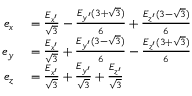<formula> <loc_0><loc_0><loc_500><loc_500>\begin{array} { r l } { e _ { x } } & = \frac { E _ { x ^ { \prime } } } { \sqrt { 3 } } - \frac { E _ { y ^ { \prime } } ( 3 + \sqrt { 3 } ) } { 6 } + \frac { E _ { z ^ { \prime } } ( 3 - \sqrt { 3 } ) } { 6 } } \\ { e _ { y } } & = \frac { E _ { x ^ { \prime } } } { \sqrt { 3 } } + \frac { E _ { y ^ { \prime } } ( 3 - \sqrt { 3 } ) } { 6 } - \frac { E _ { z ^ { \prime } } ( 3 + \sqrt { 3 } ) } { 6 } } \\ { e _ { z } } & = \frac { E _ { x ^ { \prime } } } { \sqrt { 3 } } + \frac { E _ { y ^ { \prime } } } { \sqrt { 3 } } + \frac { E _ { z ^ { \prime } } } { \sqrt { 3 } } } \end{array}</formula> 